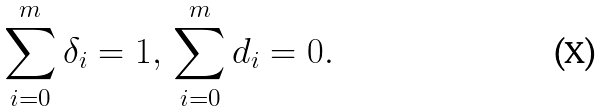Convert formula to latex. <formula><loc_0><loc_0><loc_500><loc_500>\sum _ { i = 0 } ^ { m } \delta _ { i } = 1 , \, \sum _ { i = 0 } ^ { m } d _ { i } = 0 .</formula> 